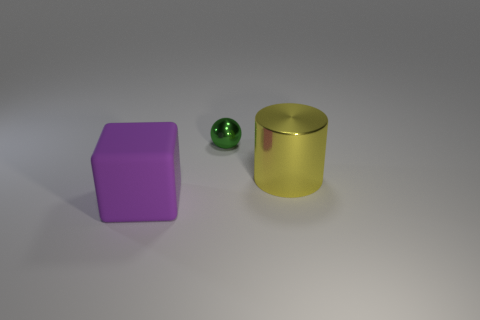How many objects are in the image, and what colors are they? There are three objects in the image. Starting from the left, there is a large purple block, a small green spherical object, and a large cylindrical gold object. 